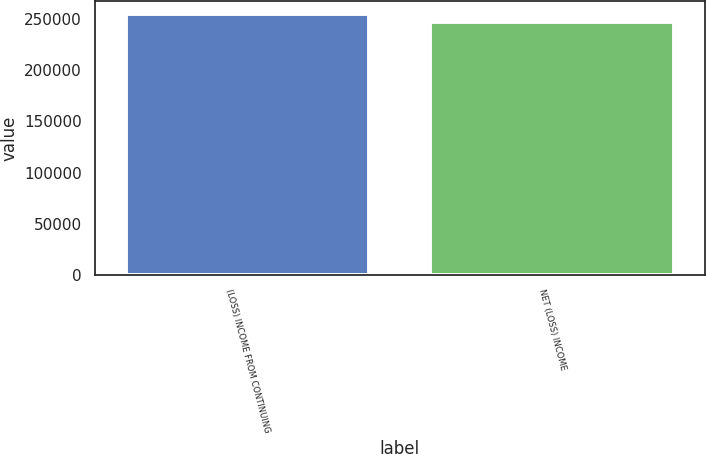<chart> <loc_0><loc_0><loc_500><loc_500><bar_chart><fcel>(LOSS) INCOME FROM CONTINUING<fcel>NET (LOSS) INCOME<nl><fcel>254764<fcel>247587<nl></chart> 